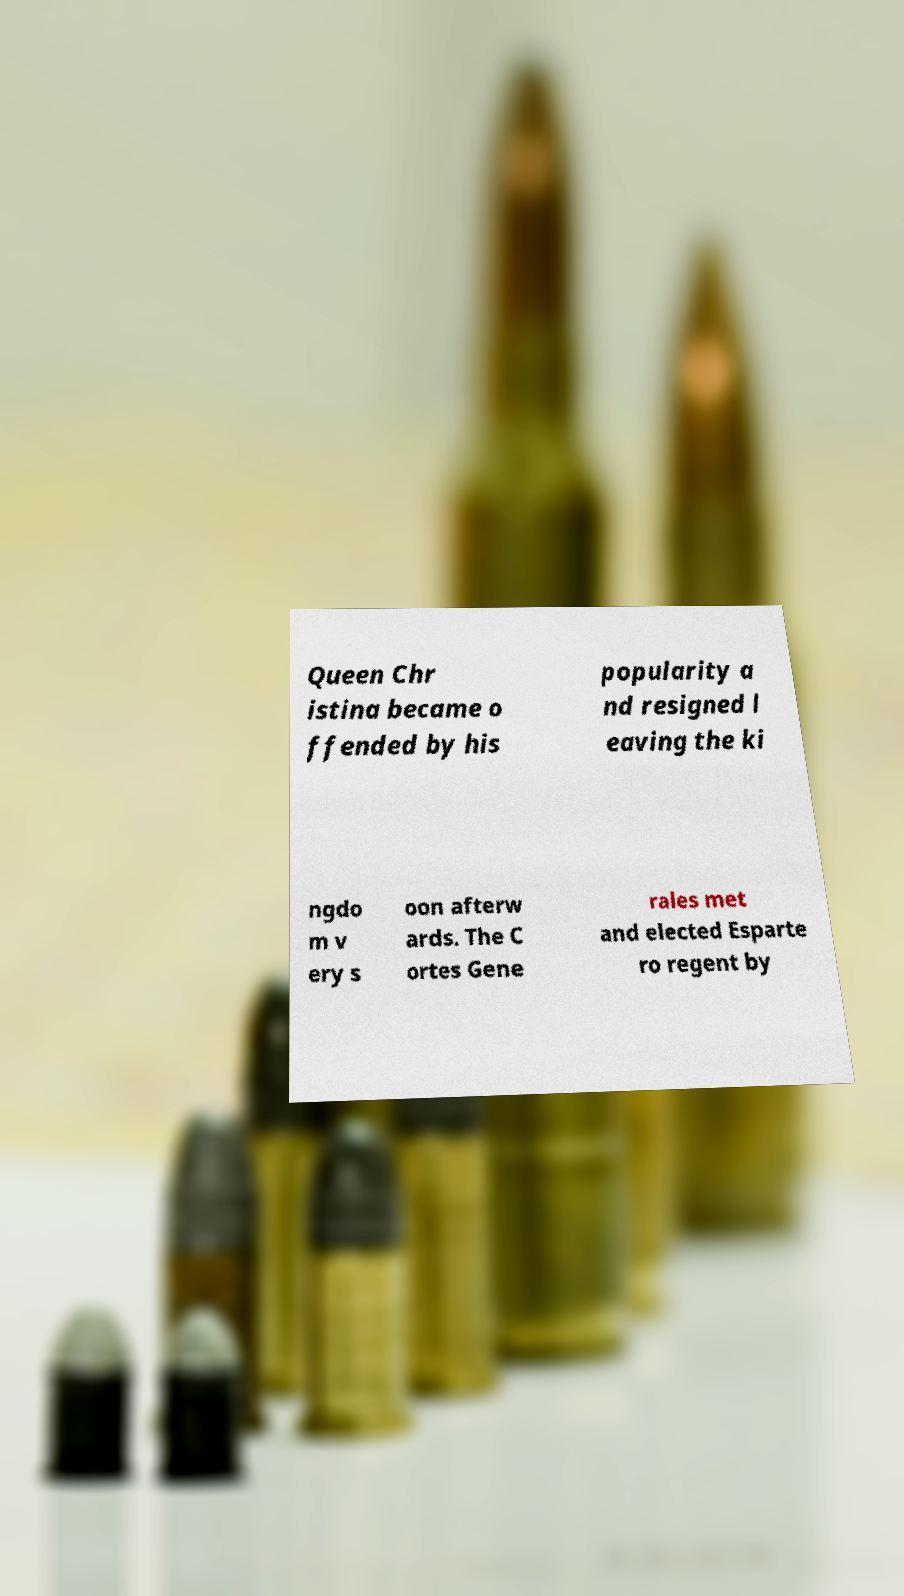There's text embedded in this image that I need extracted. Can you transcribe it verbatim? Queen Chr istina became o ffended by his popularity a nd resigned l eaving the ki ngdo m v ery s oon afterw ards. The C ortes Gene rales met and elected Esparte ro regent by 